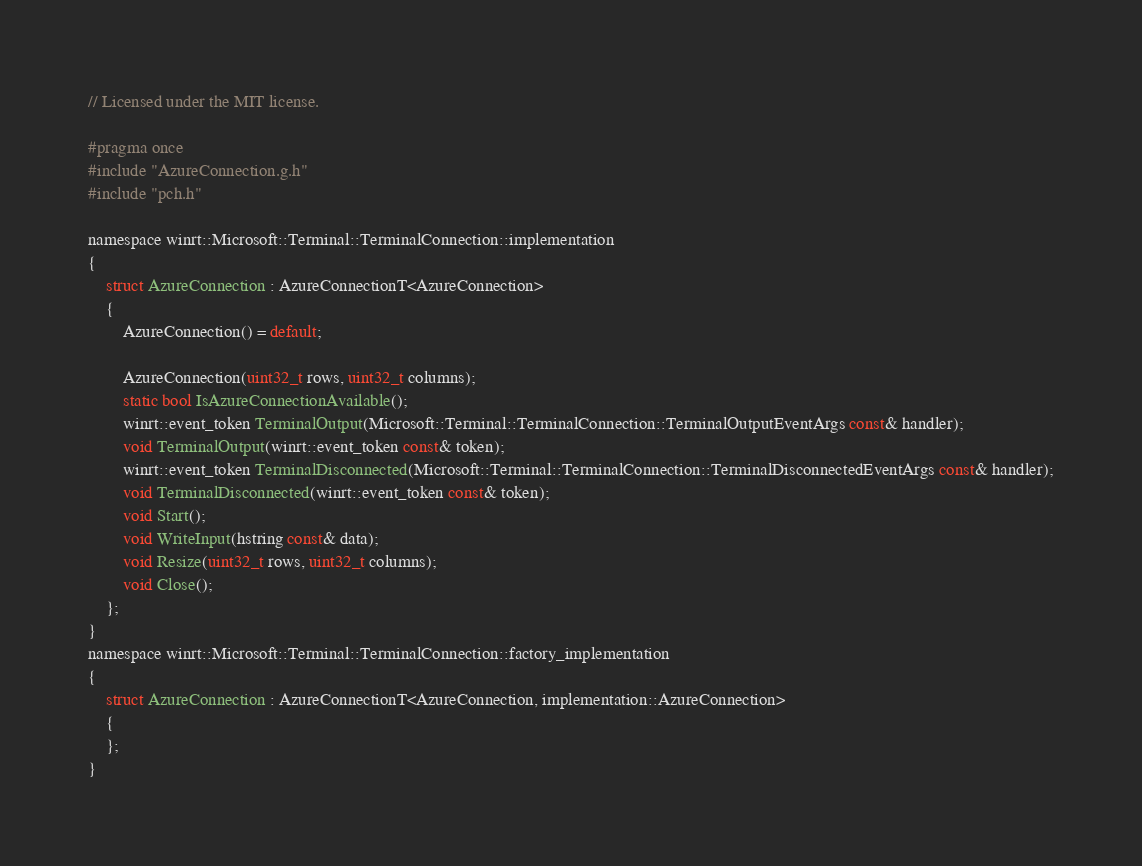<code> <loc_0><loc_0><loc_500><loc_500><_C_>// Licensed under the MIT license.

#pragma once
#include "AzureConnection.g.h"
#include "pch.h"

namespace winrt::Microsoft::Terminal::TerminalConnection::implementation
{
    struct AzureConnection : AzureConnectionT<AzureConnection>
    {
        AzureConnection() = default;

        AzureConnection(uint32_t rows, uint32_t columns);
        static bool IsAzureConnectionAvailable();
        winrt::event_token TerminalOutput(Microsoft::Terminal::TerminalConnection::TerminalOutputEventArgs const& handler);
        void TerminalOutput(winrt::event_token const& token);
        winrt::event_token TerminalDisconnected(Microsoft::Terminal::TerminalConnection::TerminalDisconnectedEventArgs const& handler);
        void TerminalDisconnected(winrt::event_token const& token);
        void Start();
        void WriteInput(hstring const& data);
        void Resize(uint32_t rows, uint32_t columns);
        void Close();
    };
}
namespace winrt::Microsoft::Terminal::TerminalConnection::factory_implementation
{
    struct AzureConnection : AzureConnectionT<AzureConnection, implementation::AzureConnection>
    {
    };
}
</code> 